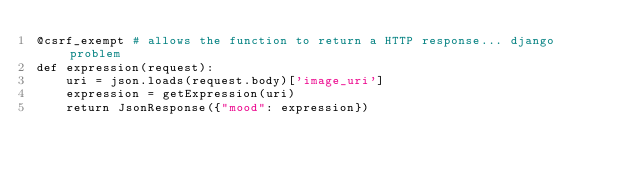Convert code to text. <code><loc_0><loc_0><loc_500><loc_500><_Python_>@csrf_exempt # allows the function to return a HTTP response... django problem
def expression(request):
    uri = json.loads(request.body)['image_uri']
    expression = getExpression(uri)
    return JsonResponse({"mood": expression})


</code> 